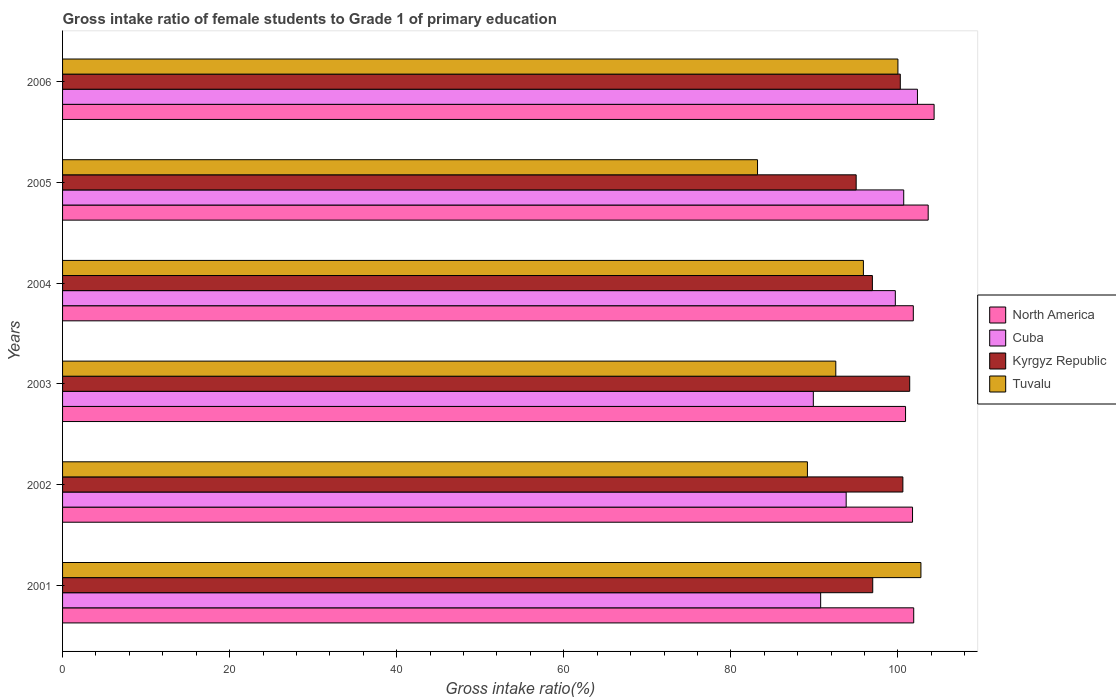How many different coloured bars are there?
Offer a very short reply. 4. How many bars are there on the 3rd tick from the bottom?
Your answer should be compact. 4. What is the label of the 6th group of bars from the top?
Make the answer very short. 2001. In how many cases, is the number of bars for a given year not equal to the number of legend labels?
Give a very brief answer. 0. What is the gross intake ratio in Cuba in 2006?
Your response must be concise. 102.34. Across all years, what is the maximum gross intake ratio in Cuba?
Keep it short and to the point. 102.34. Across all years, what is the minimum gross intake ratio in Kyrgyz Republic?
Your answer should be very brief. 95. In which year was the gross intake ratio in Tuvalu maximum?
Ensure brevity in your answer.  2001. In which year was the gross intake ratio in Tuvalu minimum?
Your response must be concise. 2005. What is the total gross intake ratio in North America in the graph?
Your answer should be compact. 614.35. What is the difference between the gross intake ratio in Kyrgyz Republic in 2001 and that in 2006?
Offer a very short reply. -3.3. What is the difference between the gross intake ratio in Tuvalu in 2004 and the gross intake ratio in Kyrgyz Republic in 2003?
Offer a terse response. -5.54. What is the average gross intake ratio in North America per year?
Keep it short and to the point. 102.39. In the year 2005, what is the difference between the gross intake ratio in Tuvalu and gross intake ratio in North America?
Give a very brief answer. -20.43. What is the ratio of the gross intake ratio in Kyrgyz Republic in 2004 to that in 2005?
Keep it short and to the point. 1.02. Is the difference between the gross intake ratio in Tuvalu in 2001 and 2003 greater than the difference between the gross intake ratio in North America in 2001 and 2003?
Your response must be concise. Yes. What is the difference between the highest and the second highest gross intake ratio in North America?
Your answer should be compact. 0.71. What is the difference between the highest and the lowest gross intake ratio in Cuba?
Make the answer very short. 12.46. In how many years, is the gross intake ratio in Cuba greater than the average gross intake ratio in Cuba taken over all years?
Make the answer very short. 3. Is it the case that in every year, the sum of the gross intake ratio in Kyrgyz Republic and gross intake ratio in Tuvalu is greater than the sum of gross intake ratio in Cuba and gross intake ratio in North America?
Keep it short and to the point. No. What does the 3rd bar from the top in 2001 represents?
Make the answer very short. Cuba. What does the 3rd bar from the bottom in 2004 represents?
Provide a succinct answer. Kyrgyz Republic. Is it the case that in every year, the sum of the gross intake ratio in Kyrgyz Republic and gross intake ratio in Cuba is greater than the gross intake ratio in Tuvalu?
Offer a terse response. Yes. How many years are there in the graph?
Your answer should be very brief. 6. What is the difference between two consecutive major ticks on the X-axis?
Make the answer very short. 20. Where does the legend appear in the graph?
Your answer should be very brief. Center right. How are the legend labels stacked?
Keep it short and to the point. Vertical. What is the title of the graph?
Ensure brevity in your answer.  Gross intake ratio of female students to Grade 1 of primary education. What is the label or title of the X-axis?
Provide a short and direct response. Gross intake ratio(%). What is the Gross intake ratio(%) of North America in 2001?
Your answer should be compact. 101.89. What is the Gross intake ratio(%) in Cuba in 2001?
Provide a short and direct response. 90.75. What is the Gross intake ratio(%) of Kyrgyz Republic in 2001?
Provide a short and direct response. 96.98. What is the Gross intake ratio(%) in Tuvalu in 2001?
Offer a terse response. 102.75. What is the Gross intake ratio(%) of North America in 2002?
Your answer should be very brief. 101.75. What is the Gross intake ratio(%) in Cuba in 2002?
Offer a terse response. 93.8. What is the Gross intake ratio(%) in Kyrgyz Republic in 2002?
Your response must be concise. 100.59. What is the Gross intake ratio(%) of Tuvalu in 2002?
Keep it short and to the point. 89.17. What is the Gross intake ratio(%) of North America in 2003?
Provide a succinct answer. 100.91. What is the Gross intake ratio(%) in Cuba in 2003?
Offer a very short reply. 89.87. What is the Gross intake ratio(%) in Kyrgyz Republic in 2003?
Ensure brevity in your answer.  101.41. What is the Gross intake ratio(%) in Tuvalu in 2003?
Keep it short and to the point. 92.56. What is the Gross intake ratio(%) of North America in 2004?
Your response must be concise. 101.84. What is the Gross intake ratio(%) of Cuba in 2004?
Your answer should be very brief. 99.69. What is the Gross intake ratio(%) of Kyrgyz Republic in 2004?
Offer a terse response. 96.94. What is the Gross intake ratio(%) of Tuvalu in 2004?
Your answer should be very brief. 95.87. What is the Gross intake ratio(%) of North America in 2005?
Your answer should be very brief. 103.62. What is the Gross intake ratio(%) in Cuba in 2005?
Give a very brief answer. 100.69. What is the Gross intake ratio(%) in Kyrgyz Republic in 2005?
Your response must be concise. 95. What is the Gross intake ratio(%) of Tuvalu in 2005?
Your answer should be compact. 83.19. What is the Gross intake ratio(%) of North America in 2006?
Give a very brief answer. 104.33. What is the Gross intake ratio(%) in Cuba in 2006?
Your answer should be compact. 102.34. What is the Gross intake ratio(%) in Kyrgyz Republic in 2006?
Make the answer very short. 100.28. What is the Gross intake ratio(%) of Tuvalu in 2006?
Make the answer very short. 100. Across all years, what is the maximum Gross intake ratio(%) of North America?
Make the answer very short. 104.33. Across all years, what is the maximum Gross intake ratio(%) in Cuba?
Give a very brief answer. 102.34. Across all years, what is the maximum Gross intake ratio(%) in Kyrgyz Republic?
Give a very brief answer. 101.41. Across all years, what is the maximum Gross intake ratio(%) in Tuvalu?
Keep it short and to the point. 102.75. Across all years, what is the minimum Gross intake ratio(%) of North America?
Provide a succinct answer. 100.91. Across all years, what is the minimum Gross intake ratio(%) in Cuba?
Ensure brevity in your answer.  89.87. Across all years, what is the minimum Gross intake ratio(%) in Kyrgyz Republic?
Your response must be concise. 95. Across all years, what is the minimum Gross intake ratio(%) in Tuvalu?
Your answer should be very brief. 83.19. What is the total Gross intake ratio(%) of North America in the graph?
Offer a terse response. 614.35. What is the total Gross intake ratio(%) of Cuba in the graph?
Offer a terse response. 577.15. What is the total Gross intake ratio(%) of Kyrgyz Republic in the graph?
Provide a succinct answer. 591.22. What is the total Gross intake ratio(%) in Tuvalu in the graph?
Keep it short and to the point. 563.54. What is the difference between the Gross intake ratio(%) in North America in 2001 and that in 2002?
Your answer should be compact. 0.14. What is the difference between the Gross intake ratio(%) in Cuba in 2001 and that in 2002?
Your answer should be compact. -3.05. What is the difference between the Gross intake ratio(%) of Kyrgyz Republic in 2001 and that in 2002?
Offer a terse response. -3.61. What is the difference between the Gross intake ratio(%) in Tuvalu in 2001 and that in 2002?
Provide a short and direct response. 13.59. What is the difference between the Gross intake ratio(%) of North America in 2001 and that in 2003?
Keep it short and to the point. 0.98. What is the difference between the Gross intake ratio(%) of Cuba in 2001 and that in 2003?
Provide a succinct answer. 0.88. What is the difference between the Gross intake ratio(%) of Kyrgyz Republic in 2001 and that in 2003?
Your answer should be very brief. -4.43. What is the difference between the Gross intake ratio(%) in Tuvalu in 2001 and that in 2003?
Your response must be concise. 10.19. What is the difference between the Gross intake ratio(%) of North America in 2001 and that in 2004?
Your answer should be compact. 0.05. What is the difference between the Gross intake ratio(%) of Cuba in 2001 and that in 2004?
Your answer should be very brief. -8.94. What is the difference between the Gross intake ratio(%) in Kyrgyz Republic in 2001 and that in 2004?
Make the answer very short. 0.04. What is the difference between the Gross intake ratio(%) in Tuvalu in 2001 and that in 2004?
Keep it short and to the point. 6.88. What is the difference between the Gross intake ratio(%) in North America in 2001 and that in 2005?
Your answer should be compact. -1.73. What is the difference between the Gross intake ratio(%) in Cuba in 2001 and that in 2005?
Ensure brevity in your answer.  -9.94. What is the difference between the Gross intake ratio(%) of Kyrgyz Republic in 2001 and that in 2005?
Your answer should be compact. 1.98. What is the difference between the Gross intake ratio(%) of Tuvalu in 2001 and that in 2005?
Your answer should be compact. 19.56. What is the difference between the Gross intake ratio(%) in North America in 2001 and that in 2006?
Ensure brevity in your answer.  -2.44. What is the difference between the Gross intake ratio(%) of Cuba in 2001 and that in 2006?
Give a very brief answer. -11.59. What is the difference between the Gross intake ratio(%) in Kyrgyz Republic in 2001 and that in 2006?
Provide a succinct answer. -3.3. What is the difference between the Gross intake ratio(%) of Tuvalu in 2001 and that in 2006?
Provide a succinct answer. 2.75. What is the difference between the Gross intake ratio(%) in North America in 2002 and that in 2003?
Provide a succinct answer. 0.84. What is the difference between the Gross intake ratio(%) in Cuba in 2002 and that in 2003?
Your answer should be very brief. 3.93. What is the difference between the Gross intake ratio(%) of Kyrgyz Republic in 2002 and that in 2003?
Offer a very short reply. -0.82. What is the difference between the Gross intake ratio(%) in Tuvalu in 2002 and that in 2003?
Give a very brief answer. -3.4. What is the difference between the Gross intake ratio(%) in North America in 2002 and that in 2004?
Make the answer very short. -0.09. What is the difference between the Gross intake ratio(%) in Cuba in 2002 and that in 2004?
Ensure brevity in your answer.  -5.89. What is the difference between the Gross intake ratio(%) in Kyrgyz Republic in 2002 and that in 2004?
Provide a succinct answer. 3.65. What is the difference between the Gross intake ratio(%) in Tuvalu in 2002 and that in 2004?
Offer a terse response. -6.7. What is the difference between the Gross intake ratio(%) in North America in 2002 and that in 2005?
Offer a terse response. -1.87. What is the difference between the Gross intake ratio(%) of Cuba in 2002 and that in 2005?
Offer a terse response. -6.89. What is the difference between the Gross intake ratio(%) in Kyrgyz Republic in 2002 and that in 2005?
Your answer should be compact. 5.59. What is the difference between the Gross intake ratio(%) in Tuvalu in 2002 and that in 2005?
Your answer should be very brief. 5.97. What is the difference between the Gross intake ratio(%) of North America in 2002 and that in 2006?
Give a very brief answer. -2.58. What is the difference between the Gross intake ratio(%) in Cuba in 2002 and that in 2006?
Ensure brevity in your answer.  -8.53. What is the difference between the Gross intake ratio(%) in Kyrgyz Republic in 2002 and that in 2006?
Make the answer very short. 0.31. What is the difference between the Gross intake ratio(%) of Tuvalu in 2002 and that in 2006?
Provide a short and direct response. -10.83. What is the difference between the Gross intake ratio(%) in North America in 2003 and that in 2004?
Your answer should be compact. -0.93. What is the difference between the Gross intake ratio(%) of Cuba in 2003 and that in 2004?
Provide a succinct answer. -9.82. What is the difference between the Gross intake ratio(%) in Kyrgyz Republic in 2003 and that in 2004?
Ensure brevity in your answer.  4.47. What is the difference between the Gross intake ratio(%) in Tuvalu in 2003 and that in 2004?
Keep it short and to the point. -3.31. What is the difference between the Gross intake ratio(%) in North America in 2003 and that in 2005?
Keep it short and to the point. -2.71. What is the difference between the Gross intake ratio(%) of Cuba in 2003 and that in 2005?
Keep it short and to the point. -10.82. What is the difference between the Gross intake ratio(%) in Kyrgyz Republic in 2003 and that in 2005?
Offer a very short reply. 6.41. What is the difference between the Gross intake ratio(%) in Tuvalu in 2003 and that in 2005?
Give a very brief answer. 9.37. What is the difference between the Gross intake ratio(%) of North America in 2003 and that in 2006?
Your answer should be compact. -3.42. What is the difference between the Gross intake ratio(%) of Cuba in 2003 and that in 2006?
Offer a very short reply. -12.46. What is the difference between the Gross intake ratio(%) in Kyrgyz Republic in 2003 and that in 2006?
Provide a short and direct response. 1.13. What is the difference between the Gross intake ratio(%) of Tuvalu in 2003 and that in 2006?
Your answer should be very brief. -7.44. What is the difference between the Gross intake ratio(%) in North America in 2004 and that in 2005?
Your response must be concise. -1.78. What is the difference between the Gross intake ratio(%) in Cuba in 2004 and that in 2005?
Offer a very short reply. -1. What is the difference between the Gross intake ratio(%) in Kyrgyz Republic in 2004 and that in 2005?
Make the answer very short. 1.94. What is the difference between the Gross intake ratio(%) in Tuvalu in 2004 and that in 2005?
Keep it short and to the point. 12.67. What is the difference between the Gross intake ratio(%) of North America in 2004 and that in 2006?
Your response must be concise. -2.49. What is the difference between the Gross intake ratio(%) in Cuba in 2004 and that in 2006?
Offer a terse response. -2.65. What is the difference between the Gross intake ratio(%) in Kyrgyz Republic in 2004 and that in 2006?
Offer a terse response. -3.34. What is the difference between the Gross intake ratio(%) of Tuvalu in 2004 and that in 2006?
Your response must be concise. -4.13. What is the difference between the Gross intake ratio(%) in North America in 2005 and that in 2006?
Your answer should be compact. -0.71. What is the difference between the Gross intake ratio(%) of Cuba in 2005 and that in 2006?
Your answer should be very brief. -1.64. What is the difference between the Gross intake ratio(%) in Kyrgyz Republic in 2005 and that in 2006?
Provide a succinct answer. -5.28. What is the difference between the Gross intake ratio(%) of Tuvalu in 2005 and that in 2006?
Offer a terse response. -16.81. What is the difference between the Gross intake ratio(%) in North America in 2001 and the Gross intake ratio(%) in Cuba in 2002?
Make the answer very short. 8.09. What is the difference between the Gross intake ratio(%) of North America in 2001 and the Gross intake ratio(%) of Kyrgyz Republic in 2002?
Give a very brief answer. 1.3. What is the difference between the Gross intake ratio(%) of North America in 2001 and the Gross intake ratio(%) of Tuvalu in 2002?
Make the answer very short. 12.72. What is the difference between the Gross intake ratio(%) in Cuba in 2001 and the Gross intake ratio(%) in Kyrgyz Republic in 2002?
Offer a terse response. -9.84. What is the difference between the Gross intake ratio(%) in Cuba in 2001 and the Gross intake ratio(%) in Tuvalu in 2002?
Keep it short and to the point. 1.58. What is the difference between the Gross intake ratio(%) of Kyrgyz Republic in 2001 and the Gross intake ratio(%) of Tuvalu in 2002?
Offer a terse response. 7.82. What is the difference between the Gross intake ratio(%) of North America in 2001 and the Gross intake ratio(%) of Cuba in 2003?
Offer a terse response. 12.02. What is the difference between the Gross intake ratio(%) in North America in 2001 and the Gross intake ratio(%) in Kyrgyz Republic in 2003?
Make the answer very short. 0.48. What is the difference between the Gross intake ratio(%) of North America in 2001 and the Gross intake ratio(%) of Tuvalu in 2003?
Offer a very short reply. 9.33. What is the difference between the Gross intake ratio(%) of Cuba in 2001 and the Gross intake ratio(%) of Kyrgyz Republic in 2003?
Make the answer very short. -10.66. What is the difference between the Gross intake ratio(%) of Cuba in 2001 and the Gross intake ratio(%) of Tuvalu in 2003?
Ensure brevity in your answer.  -1.81. What is the difference between the Gross intake ratio(%) in Kyrgyz Republic in 2001 and the Gross intake ratio(%) in Tuvalu in 2003?
Your answer should be compact. 4.42. What is the difference between the Gross intake ratio(%) of North America in 2001 and the Gross intake ratio(%) of Cuba in 2004?
Your response must be concise. 2.2. What is the difference between the Gross intake ratio(%) of North America in 2001 and the Gross intake ratio(%) of Kyrgyz Republic in 2004?
Ensure brevity in your answer.  4.95. What is the difference between the Gross intake ratio(%) in North America in 2001 and the Gross intake ratio(%) in Tuvalu in 2004?
Ensure brevity in your answer.  6.02. What is the difference between the Gross intake ratio(%) of Cuba in 2001 and the Gross intake ratio(%) of Kyrgyz Republic in 2004?
Keep it short and to the point. -6.19. What is the difference between the Gross intake ratio(%) in Cuba in 2001 and the Gross intake ratio(%) in Tuvalu in 2004?
Keep it short and to the point. -5.12. What is the difference between the Gross intake ratio(%) in Kyrgyz Republic in 2001 and the Gross intake ratio(%) in Tuvalu in 2004?
Keep it short and to the point. 1.12. What is the difference between the Gross intake ratio(%) in North America in 2001 and the Gross intake ratio(%) in Cuba in 2005?
Keep it short and to the point. 1.2. What is the difference between the Gross intake ratio(%) in North America in 2001 and the Gross intake ratio(%) in Kyrgyz Republic in 2005?
Provide a succinct answer. 6.89. What is the difference between the Gross intake ratio(%) of North America in 2001 and the Gross intake ratio(%) of Tuvalu in 2005?
Offer a terse response. 18.7. What is the difference between the Gross intake ratio(%) of Cuba in 2001 and the Gross intake ratio(%) of Kyrgyz Republic in 2005?
Give a very brief answer. -4.25. What is the difference between the Gross intake ratio(%) of Cuba in 2001 and the Gross intake ratio(%) of Tuvalu in 2005?
Your answer should be very brief. 7.56. What is the difference between the Gross intake ratio(%) in Kyrgyz Republic in 2001 and the Gross intake ratio(%) in Tuvalu in 2005?
Your response must be concise. 13.79. What is the difference between the Gross intake ratio(%) of North America in 2001 and the Gross intake ratio(%) of Cuba in 2006?
Provide a succinct answer. -0.45. What is the difference between the Gross intake ratio(%) of North America in 2001 and the Gross intake ratio(%) of Kyrgyz Republic in 2006?
Your response must be concise. 1.61. What is the difference between the Gross intake ratio(%) in North America in 2001 and the Gross intake ratio(%) in Tuvalu in 2006?
Your answer should be compact. 1.89. What is the difference between the Gross intake ratio(%) of Cuba in 2001 and the Gross intake ratio(%) of Kyrgyz Republic in 2006?
Give a very brief answer. -9.53. What is the difference between the Gross intake ratio(%) in Cuba in 2001 and the Gross intake ratio(%) in Tuvalu in 2006?
Offer a terse response. -9.25. What is the difference between the Gross intake ratio(%) in Kyrgyz Republic in 2001 and the Gross intake ratio(%) in Tuvalu in 2006?
Your response must be concise. -3.02. What is the difference between the Gross intake ratio(%) of North America in 2002 and the Gross intake ratio(%) of Cuba in 2003?
Your answer should be compact. 11.87. What is the difference between the Gross intake ratio(%) in North America in 2002 and the Gross intake ratio(%) in Kyrgyz Republic in 2003?
Your response must be concise. 0.34. What is the difference between the Gross intake ratio(%) of North America in 2002 and the Gross intake ratio(%) of Tuvalu in 2003?
Your answer should be compact. 9.19. What is the difference between the Gross intake ratio(%) of Cuba in 2002 and the Gross intake ratio(%) of Kyrgyz Republic in 2003?
Offer a very short reply. -7.61. What is the difference between the Gross intake ratio(%) of Cuba in 2002 and the Gross intake ratio(%) of Tuvalu in 2003?
Provide a short and direct response. 1.24. What is the difference between the Gross intake ratio(%) in Kyrgyz Republic in 2002 and the Gross intake ratio(%) in Tuvalu in 2003?
Your answer should be compact. 8.03. What is the difference between the Gross intake ratio(%) in North America in 2002 and the Gross intake ratio(%) in Cuba in 2004?
Offer a terse response. 2.06. What is the difference between the Gross intake ratio(%) of North America in 2002 and the Gross intake ratio(%) of Kyrgyz Republic in 2004?
Keep it short and to the point. 4.8. What is the difference between the Gross intake ratio(%) of North America in 2002 and the Gross intake ratio(%) of Tuvalu in 2004?
Provide a succinct answer. 5.88. What is the difference between the Gross intake ratio(%) in Cuba in 2002 and the Gross intake ratio(%) in Kyrgyz Republic in 2004?
Your answer should be very brief. -3.14. What is the difference between the Gross intake ratio(%) of Cuba in 2002 and the Gross intake ratio(%) of Tuvalu in 2004?
Ensure brevity in your answer.  -2.06. What is the difference between the Gross intake ratio(%) of Kyrgyz Republic in 2002 and the Gross intake ratio(%) of Tuvalu in 2004?
Ensure brevity in your answer.  4.73. What is the difference between the Gross intake ratio(%) of North America in 2002 and the Gross intake ratio(%) of Cuba in 2005?
Keep it short and to the point. 1.05. What is the difference between the Gross intake ratio(%) of North America in 2002 and the Gross intake ratio(%) of Kyrgyz Republic in 2005?
Give a very brief answer. 6.75. What is the difference between the Gross intake ratio(%) in North America in 2002 and the Gross intake ratio(%) in Tuvalu in 2005?
Offer a terse response. 18.55. What is the difference between the Gross intake ratio(%) in Cuba in 2002 and the Gross intake ratio(%) in Kyrgyz Republic in 2005?
Give a very brief answer. -1.2. What is the difference between the Gross intake ratio(%) of Cuba in 2002 and the Gross intake ratio(%) of Tuvalu in 2005?
Ensure brevity in your answer.  10.61. What is the difference between the Gross intake ratio(%) in North America in 2002 and the Gross intake ratio(%) in Cuba in 2006?
Your answer should be compact. -0.59. What is the difference between the Gross intake ratio(%) of North America in 2002 and the Gross intake ratio(%) of Kyrgyz Republic in 2006?
Offer a terse response. 1.46. What is the difference between the Gross intake ratio(%) of North America in 2002 and the Gross intake ratio(%) of Tuvalu in 2006?
Give a very brief answer. 1.75. What is the difference between the Gross intake ratio(%) in Cuba in 2002 and the Gross intake ratio(%) in Kyrgyz Republic in 2006?
Provide a short and direct response. -6.48. What is the difference between the Gross intake ratio(%) in Cuba in 2002 and the Gross intake ratio(%) in Tuvalu in 2006?
Offer a very short reply. -6.2. What is the difference between the Gross intake ratio(%) of Kyrgyz Republic in 2002 and the Gross intake ratio(%) of Tuvalu in 2006?
Give a very brief answer. 0.59. What is the difference between the Gross intake ratio(%) in North America in 2003 and the Gross intake ratio(%) in Cuba in 2004?
Make the answer very short. 1.22. What is the difference between the Gross intake ratio(%) in North America in 2003 and the Gross intake ratio(%) in Kyrgyz Republic in 2004?
Ensure brevity in your answer.  3.97. What is the difference between the Gross intake ratio(%) in North America in 2003 and the Gross intake ratio(%) in Tuvalu in 2004?
Your answer should be compact. 5.04. What is the difference between the Gross intake ratio(%) of Cuba in 2003 and the Gross intake ratio(%) of Kyrgyz Republic in 2004?
Your response must be concise. -7.07. What is the difference between the Gross intake ratio(%) in Cuba in 2003 and the Gross intake ratio(%) in Tuvalu in 2004?
Your answer should be compact. -5.99. What is the difference between the Gross intake ratio(%) of Kyrgyz Republic in 2003 and the Gross intake ratio(%) of Tuvalu in 2004?
Your answer should be very brief. 5.54. What is the difference between the Gross intake ratio(%) in North America in 2003 and the Gross intake ratio(%) in Cuba in 2005?
Give a very brief answer. 0.22. What is the difference between the Gross intake ratio(%) in North America in 2003 and the Gross intake ratio(%) in Kyrgyz Republic in 2005?
Your answer should be very brief. 5.91. What is the difference between the Gross intake ratio(%) in North America in 2003 and the Gross intake ratio(%) in Tuvalu in 2005?
Your answer should be very brief. 17.72. What is the difference between the Gross intake ratio(%) in Cuba in 2003 and the Gross intake ratio(%) in Kyrgyz Republic in 2005?
Provide a succinct answer. -5.13. What is the difference between the Gross intake ratio(%) in Cuba in 2003 and the Gross intake ratio(%) in Tuvalu in 2005?
Make the answer very short. 6.68. What is the difference between the Gross intake ratio(%) of Kyrgyz Republic in 2003 and the Gross intake ratio(%) of Tuvalu in 2005?
Provide a short and direct response. 18.22. What is the difference between the Gross intake ratio(%) of North America in 2003 and the Gross intake ratio(%) of Cuba in 2006?
Offer a terse response. -1.43. What is the difference between the Gross intake ratio(%) of North America in 2003 and the Gross intake ratio(%) of Kyrgyz Republic in 2006?
Make the answer very short. 0.63. What is the difference between the Gross intake ratio(%) in North America in 2003 and the Gross intake ratio(%) in Tuvalu in 2006?
Offer a very short reply. 0.91. What is the difference between the Gross intake ratio(%) of Cuba in 2003 and the Gross intake ratio(%) of Kyrgyz Republic in 2006?
Ensure brevity in your answer.  -10.41. What is the difference between the Gross intake ratio(%) of Cuba in 2003 and the Gross intake ratio(%) of Tuvalu in 2006?
Your answer should be very brief. -10.13. What is the difference between the Gross intake ratio(%) of Kyrgyz Republic in 2003 and the Gross intake ratio(%) of Tuvalu in 2006?
Your answer should be very brief. 1.41. What is the difference between the Gross intake ratio(%) in North America in 2004 and the Gross intake ratio(%) in Cuba in 2005?
Make the answer very short. 1.15. What is the difference between the Gross intake ratio(%) in North America in 2004 and the Gross intake ratio(%) in Kyrgyz Republic in 2005?
Offer a terse response. 6.84. What is the difference between the Gross intake ratio(%) in North America in 2004 and the Gross intake ratio(%) in Tuvalu in 2005?
Provide a succinct answer. 18.65. What is the difference between the Gross intake ratio(%) of Cuba in 2004 and the Gross intake ratio(%) of Kyrgyz Republic in 2005?
Your answer should be compact. 4.69. What is the difference between the Gross intake ratio(%) in Cuba in 2004 and the Gross intake ratio(%) in Tuvalu in 2005?
Offer a very short reply. 16.5. What is the difference between the Gross intake ratio(%) in Kyrgyz Republic in 2004 and the Gross intake ratio(%) in Tuvalu in 2005?
Keep it short and to the point. 13.75. What is the difference between the Gross intake ratio(%) of North America in 2004 and the Gross intake ratio(%) of Cuba in 2006?
Provide a short and direct response. -0.5. What is the difference between the Gross intake ratio(%) of North America in 2004 and the Gross intake ratio(%) of Kyrgyz Republic in 2006?
Make the answer very short. 1.56. What is the difference between the Gross intake ratio(%) in North America in 2004 and the Gross intake ratio(%) in Tuvalu in 2006?
Ensure brevity in your answer.  1.84. What is the difference between the Gross intake ratio(%) of Cuba in 2004 and the Gross intake ratio(%) of Kyrgyz Republic in 2006?
Provide a succinct answer. -0.59. What is the difference between the Gross intake ratio(%) in Cuba in 2004 and the Gross intake ratio(%) in Tuvalu in 2006?
Offer a very short reply. -0.31. What is the difference between the Gross intake ratio(%) in Kyrgyz Republic in 2004 and the Gross intake ratio(%) in Tuvalu in 2006?
Give a very brief answer. -3.06. What is the difference between the Gross intake ratio(%) of North America in 2005 and the Gross intake ratio(%) of Cuba in 2006?
Provide a succinct answer. 1.29. What is the difference between the Gross intake ratio(%) in North America in 2005 and the Gross intake ratio(%) in Kyrgyz Republic in 2006?
Make the answer very short. 3.34. What is the difference between the Gross intake ratio(%) in North America in 2005 and the Gross intake ratio(%) in Tuvalu in 2006?
Give a very brief answer. 3.62. What is the difference between the Gross intake ratio(%) in Cuba in 2005 and the Gross intake ratio(%) in Kyrgyz Republic in 2006?
Your answer should be compact. 0.41. What is the difference between the Gross intake ratio(%) of Cuba in 2005 and the Gross intake ratio(%) of Tuvalu in 2006?
Make the answer very short. 0.69. What is the difference between the Gross intake ratio(%) in Kyrgyz Republic in 2005 and the Gross intake ratio(%) in Tuvalu in 2006?
Offer a terse response. -5. What is the average Gross intake ratio(%) in North America per year?
Keep it short and to the point. 102.39. What is the average Gross intake ratio(%) of Cuba per year?
Your answer should be very brief. 96.19. What is the average Gross intake ratio(%) in Kyrgyz Republic per year?
Ensure brevity in your answer.  98.54. What is the average Gross intake ratio(%) of Tuvalu per year?
Your answer should be very brief. 93.92. In the year 2001, what is the difference between the Gross intake ratio(%) in North America and Gross intake ratio(%) in Cuba?
Offer a terse response. 11.14. In the year 2001, what is the difference between the Gross intake ratio(%) in North America and Gross intake ratio(%) in Kyrgyz Republic?
Offer a terse response. 4.91. In the year 2001, what is the difference between the Gross intake ratio(%) in North America and Gross intake ratio(%) in Tuvalu?
Your response must be concise. -0.86. In the year 2001, what is the difference between the Gross intake ratio(%) in Cuba and Gross intake ratio(%) in Kyrgyz Republic?
Make the answer very short. -6.23. In the year 2001, what is the difference between the Gross intake ratio(%) of Cuba and Gross intake ratio(%) of Tuvalu?
Provide a succinct answer. -12. In the year 2001, what is the difference between the Gross intake ratio(%) in Kyrgyz Republic and Gross intake ratio(%) in Tuvalu?
Your answer should be very brief. -5.77. In the year 2002, what is the difference between the Gross intake ratio(%) in North America and Gross intake ratio(%) in Cuba?
Ensure brevity in your answer.  7.94. In the year 2002, what is the difference between the Gross intake ratio(%) in North America and Gross intake ratio(%) in Kyrgyz Republic?
Provide a short and direct response. 1.15. In the year 2002, what is the difference between the Gross intake ratio(%) of North America and Gross intake ratio(%) of Tuvalu?
Give a very brief answer. 12.58. In the year 2002, what is the difference between the Gross intake ratio(%) of Cuba and Gross intake ratio(%) of Kyrgyz Republic?
Your answer should be very brief. -6.79. In the year 2002, what is the difference between the Gross intake ratio(%) of Cuba and Gross intake ratio(%) of Tuvalu?
Make the answer very short. 4.64. In the year 2002, what is the difference between the Gross intake ratio(%) of Kyrgyz Republic and Gross intake ratio(%) of Tuvalu?
Your answer should be compact. 11.43. In the year 2003, what is the difference between the Gross intake ratio(%) in North America and Gross intake ratio(%) in Cuba?
Provide a succinct answer. 11.04. In the year 2003, what is the difference between the Gross intake ratio(%) of North America and Gross intake ratio(%) of Kyrgyz Republic?
Your response must be concise. -0.5. In the year 2003, what is the difference between the Gross intake ratio(%) in North America and Gross intake ratio(%) in Tuvalu?
Your response must be concise. 8.35. In the year 2003, what is the difference between the Gross intake ratio(%) in Cuba and Gross intake ratio(%) in Kyrgyz Republic?
Offer a very short reply. -11.54. In the year 2003, what is the difference between the Gross intake ratio(%) of Cuba and Gross intake ratio(%) of Tuvalu?
Your response must be concise. -2.69. In the year 2003, what is the difference between the Gross intake ratio(%) of Kyrgyz Republic and Gross intake ratio(%) of Tuvalu?
Offer a terse response. 8.85. In the year 2004, what is the difference between the Gross intake ratio(%) in North America and Gross intake ratio(%) in Cuba?
Keep it short and to the point. 2.15. In the year 2004, what is the difference between the Gross intake ratio(%) of North America and Gross intake ratio(%) of Kyrgyz Republic?
Ensure brevity in your answer.  4.9. In the year 2004, what is the difference between the Gross intake ratio(%) of North America and Gross intake ratio(%) of Tuvalu?
Provide a short and direct response. 5.97. In the year 2004, what is the difference between the Gross intake ratio(%) in Cuba and Gross intake ratio(%) in Kyrgyz Republic?
Your answer should be very brief. 2.75. In the year 2004, what is the difference between the Gross intake ratio(%) in Cuba and Gross intake ratio(%) in Tuvalu?
Your answer should be compact. 3.82. In the year 2004, what is the difference between the Gross intake ratio(%) in Kyrgyz Republic and Gross intake ratio(%) in Tuvalu?
Your response must be concise. 1.08. In the year 2005, what is the difference between the Gross intake ratio(%) in North America and Gross intake ratio(%) in Cuba?
Make the answer very short. 2.93. In the year 2005, what is the difference between the Gross intake ratio(%) of North America and Gross intake ratio(%) of Kyrgyz Republic?
Keep it short and to the point. 8.62. In the year 2005, what is the difference between the Gross intake ratio(%) of North America and Gross intake ratio(%) of Tuvalu?
Offer a very short reply. 20.43. In the year 2005, what is the difference between the Gross intake ratio(%) of Cuba and Gross intake ratio(%) of Kyrgyz Republic?
Give a very brief answer. 5.69. In the year 2005, what is the difference between the Gross intake ratio(%) of Cuba and Gross intake ratio(%) of Tuvalu?
Make the answer very short. 17.5. In the year 2005, what is the difference between the Gross intake ratio(%) in Kyrgyz Republic and Gross intake ratio(%) in Tuvalu?
Provide a short and direct response. 11.81. In the year 2006, what is the difference between the Gross intake ratio(%) in North America and Gross intake ratio(%) in Cuba?
Your response must be concise. 1.99. In the year 2006, what is the difference between the Gross intake ratio(%) of North America and Gross intake ratio(%) of Kyrgyz Republic?
Make the answer very short. 4.05. In the year 2006, what is the difference between the Gross intake ratio(%) in North America and Gross intake ratio(%) in Tuvalu?
Make the answer very short. 4.33. In the year 2006, what is the difference between the Gross intake ratio(%) of Cuba and Gross intake ratio(%) of Kyrgyz Republic?
Give a very brief answer. 2.05. In the year 2006, what is the difference between the Gross intake ratio(%) of Cuba and Gross intake ratio(%) of Tuvalu?
Make the answer very short. 2.34. In the year 2006, what is the difference between the Gross intake ratio(%) in Kyrgyz Republic and Gross intake ratio(%) in Tuvalu?
Make the answer very short. 0.28. What is the ratio of the Gross intake ratio(%) of North America in 2001 to that in 2002?
Provide a short and direct response. 1. What is the ratio of the Gross intake ratio(%) in Cuba in 2001 to that in 2002?
Give a very brief answer. 0.97. What is the ratio of the Gross intake ratio(%) of Kyrgyz Republic in 2001 to that in 2002?
Offer a terse response. 0.96. What is the ratio of the Gross intake ratio(%) of Tuvalu in 2001 to that in 2002?
Your answer should be very brief. 1.15. What is the ratio of the Gross intake ratio(%) in North America in 2001 to that in 2003?
Your answer should be compact. 1.01. What is the ratio of the Gross intake ratio(%) of Cuba in 2001 to that in 2003?
Provide a succinct answer. 1.01. What is the ratio of the Gross intake ratio(%) of Kyrgyz Republic in 2001 to that in 2003?
Ensure brevity in your answer.  0.96. What is the ratio of the Gross intake ratio(%) of Tuvalu in 2001 to that in 2003?
Give a very brief answer. 1.11. What is the ratio of the Gross intake ratio(%) in North America in 2001 to that in 2004?
Your answer should be compact. 1. What is the ratio of the Gross intake ratio(%) in Cuba in 2001 to that in 2004?
Your answer should be very brief. 0.91. What is the ratio of the Gross intake ratio(%) of Kyrgyz Republic in 2001 to that in 2004?
Give a very brief answer. 1. What is the ratio of the Gross intake ratio(%) in Tuvalu in 2001 to that in 2004?
Provide a short and direct response. 1.07. What is the ratio of the Gross intake ratio(%) in North America in 2001 to that in 2005?
Offer a very short reply. 0.98. What is the ratio of the Gross intake ratio(%) in Cuba in 2001 to that in 2005?
Your response must be concise. 0.9. What is the ratio of the Gross intake ratio(%) in Kyrgyz Republic in 2001 to that in 2005?
Provide a succinct answer. 1.02. What is the ratio of the Gross intake ratio(%) in Tuvalu in 2001 to that in 2005?
Make the answer very short. 1.24. What is the ratio of the Gross intake ratio(%) of North America in 2001 to that in 2006?
Provide a succinct answer. 0.98. What is the ratio of the Gross intake ratio(%) of Cuba in 2001 to that in 2006?
Provide a short and direct response. 0.89. What is the ratio of the Gross intake ratio(%) of Kyrgyz Republic in 2001 to that in 2006?
Ensure brevity in your answer.  0.97. What is the ratio of the Gross intake ratio(%) in Tuvalu in 2001 to that in 2006?
Your response must be concise. 1.03. What is the ratio of the Gross intake ratio(%) of North America in 2002 to that in 2003?
Make the answer very short. 1.01. What is the ratio of the Gross intake ratio(%) of Cuba in 2002 to that in 2003?
Your answer should be compact. 1.04. What is the ratio of the Gross intake ratio(%) in Kyrgyz Republic in 2002 to that in 2003?
Your response must be concise. 0.99. What is the ratio of the Gross intake ratio(%) of Tuvalu in 2002 to that in 2003?
Offer a very short reply. 0.96. What is the ratio of the Gross intake ratio(%) in North America in 2002 to that in 2004?
Make the answer very short. 1. What is the ratio of the Gross intake ratio(%) of Cuba in 2002 to that in 2004?
Make the answer very short. 0.94. What is the ratio of the Gross intake ratio(%) in Kyrgyz Republic in 2002 to that in 2004?
Offer a terse response. 1.04. What is the ratio of the Gross intake ratio(%) in Tuvalu in 2002 to that in 2004?
Your response must be concise. 0.93. What is the ratio of the Gross intake ratio(%) of North America in 2002 to that in 2005?
Ensure brevity in your answer.  0.98. What is the ratio of the Gross intake ratio(%) in Cuba in 2002 to that in 2005?
Your answer should be very brief. 0.93. What is the ratio of the Gross intake ratio(%) of Kyrgyz Republic in 2002 to that in 2005?
Offer a very short reply. 1.06. What is the ratio of the Gross intake ratio(%) of Tuvalu in 2002 to that in 2005?
Provide a short and direct response. 1.07. What is the ratio of the Gross intake ratio(%) in North America in 2002 to that in 2006?
Your answer should be very brief. 0.98. What is the ratio of the Gross intake ratio(%) of Cuba in 2002 to that in 2006?
Ensure brevity in your answer.  0.92. What is the ratio of the Gross intake ratio(%) of Kyrgyz Republic in 2002 to that in 2006?
Make the answer very short. 1. What is the ratio of the Gross intake ratio(%) in Tuvalu in 2002 to that in 2006?
Your answer should be very brief. 0.89. What is the ratio of the Gross intake ratio(%) of North America in 2003 to that in 2004?
Provide a short and direct response. 0.99. What is the ratio of the Gross intake ratio(%) in Cuba in 2003 to that in 2004?
Offer a terse response. 0.9. What is the ratio of the Gross intake ratio(%) in Kyrgyz Republic in 2003 to that in 2004?
Offer a very short reply. 1.05. What is the ratio of the Gross intake ratio(%) in Tuvalu in 2003 to that in 2004?
Provide a short and direct response. 0.97. What is the ratio of the Gross intake ratio(%) in North America in 2003 to that in 2005?
Provide a short and direct response. 0.97. What is the ratio of the Gross intake ratio(%) in Cuba in 2003 to that in 2005?
Offer a terse response. 0.89. What is the ratio of the Gross intake ratio(%) in Kyrgyz Republic in 2003 to that in 2005?
Offer a terse response. 1.07. What is the ratio of the Gross intake ratio(%) of Tuvalu in 2003 to that in 2005?
Provide a succinct answer. 1.11. What is the ratio of the Gross intake ratio(%) in North America in 2003 to that in 2006?
Your response must be concise. 0.97. What is the ratio of the Gross intake ratio(%) in Cuba in 2003 to that in 2006?
Your answer should be very brief. 0.88. What is the ratio of the Gross intake ratio(%) in Kyrgyz Republic in 2003 to that in 2006?
Your answer should be compact. 1.01. What is the ratio of the Gross intake ratio(%) of Tuvalu in 2003 to that in 2006?
Give a very brief answer. 0.93. What is the ratio of the Gross intake ratio(%) of North America in 2004 to that in 2005?
Provide a short and direct response. 0.98. What is the ratio of the Gross intake ratio(%) of Cuba in 2004 to that in 2005?
Make the answer very short. 0.99. What is the ratio of the Gross intake ratio(%) of Kyrgyz Republic in 2004 to that in 2005?
Provide a short and direct response. 1.02. What is the ratio of the Gross intake ratio(%) in Tuvalu in 2004 to that in 2005?
Provide a succinct answer. 1.15. What is the ratio of the Gross intake ratio(%) of North America in 2004 to that in 2006?
Ensure brevity in your answer.  0.98. What is the ratio of the Gross intake ratio(%) of Cuba in 2004 to that in 2006?
Ensure brevity in your answer.  0.97. What is the ratio of the Gross intake ratio(%) of Kyrgyz Republic in 2004 to that in 2006?
Your answer should be compact. 0.97. What is the ratio of the Gross intake ratio(%) of Tuvalu in 2004 to that in 2006?
Ensure brevity in your answer.  0.96. What is the ratio of the Gross intake ratio(%) in Cuba in 2005 to that in 2006?
Offer a very short reply. 0.98. What is the ratio of the Gross intake ratio(%) in Kyrgyz Republic in 2005 to that in 2006?
Give a very brief answer. 0.95. What is the ratio of the Gross intake ratio(%) of Tuvalu in 2005 to that in 2006?
Provide a short and direct response. 0.83. What is the difference between the highest and the second highest Gross intake ratio(%) in North America?
Your response must be concise. 0.71. What is the difference between the highest and the second highest Gross intake ratio(%) of Cuba?
Give a very brief answer. 1.64. What is the difference between the highest and the second highest Gross intake ratio(%) of Kyrgyz Republic?
Your response must be concise. 0.82. What is the difference between the highest and the second highest Gross intake ratio(%) of Tuvalu?
Offer a very short reply. 2.75. What is the difference between the highest and the lowest Gross intake ratio(%) in North America?
Give a very brief answer. 3.42. What is the difference between the highest and the lowest Gross intake ratio(%) of Cuba?
Give a very brief answer. 12.46. What is the difference between the highest and the lowest Gross intake ratio(%) in Kyrgyz Republic?
Your answer should be compact. 6.41. What is the difference between the highest and the lowest Gross intake ratio(%) of Tuvalu?
Offer a very short reply. 19.56. 